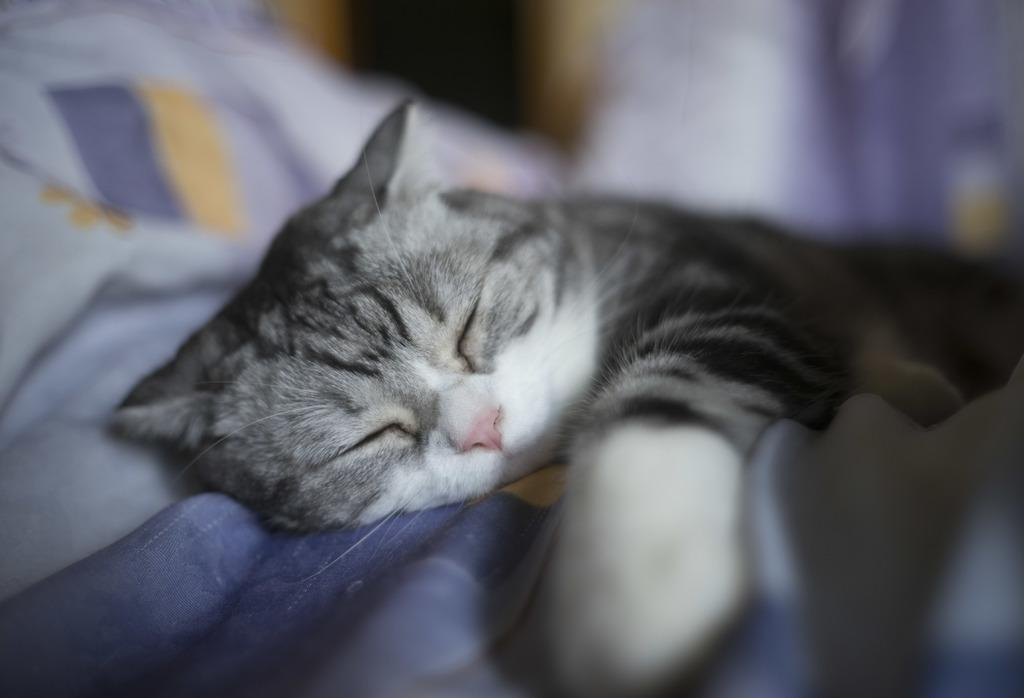What type of animal is in the image? There is a cat in the image. What is the cat doing in the image? The cat is sleeping on the bed. What can be seen on the bed? The bed appears to have a bed sheet. Can you describe the background of the image? The background of the image is blurry. What type of structure can be seen in the background of the image? There is no structure visible in the background of the image; it is blurry. Can you tell me how many geese are present in the image? There are no geese present in the image; it features a cat sleeping on a bed. 